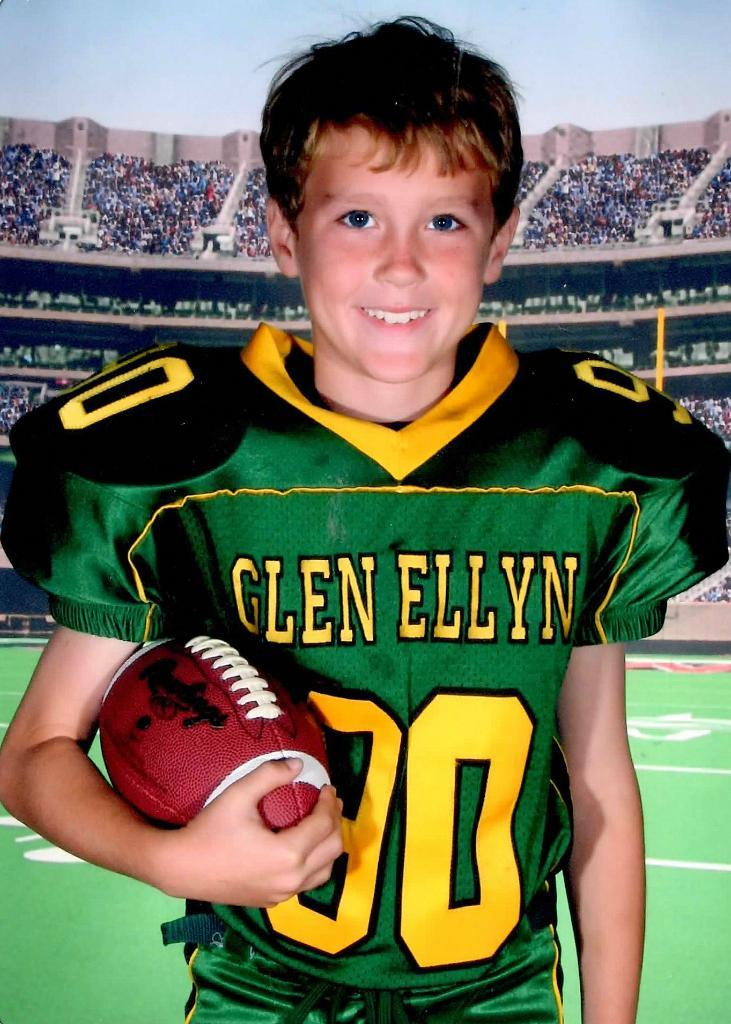<image>
Share a concise interpretation of the image provided. A young boy wearing a football jersey with the name Glen Ellyn on it. 